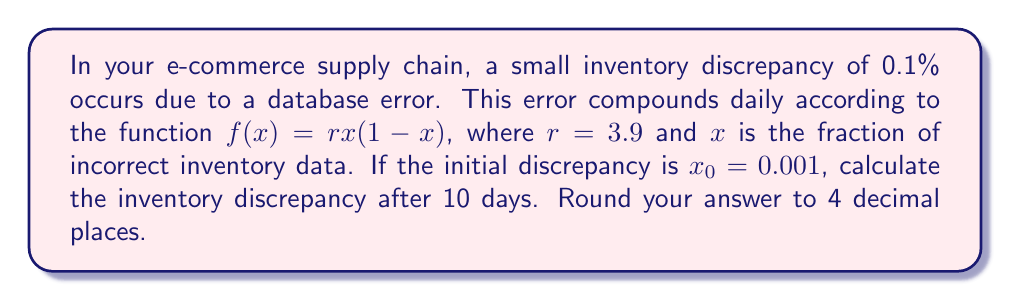Help me with this question. To solve this problem, we need to iterate the function $f(x) = rx(1-x)$ 10 times, starting with $x_0 = 0.001$. This is a classic example of the logistic map, which exhibits chaotic behavior for $r > 3.57$.

Let's calculate step by step:

1) $x_1 = f(x_0) = 3.9 \cdot 0.001 \cdot (1-0.001) = 0.0038961$

2) $x_2 = f(x_1) = 3.9 \cdot 0.0038961 \cdot (1-0.0038961) = 0.0151374$

3) $x_3 = f(x_2) = 3.9 \cdot 0.0151374 \cdot (1-0.0151374) = 0.0578654$

4) $x_4 = f(x_3) = 3.9 \cdot 0.0578654 \cdot (1-0.0578654) = 0.2126219$

5) $x_5 = f(x_4) = 3.9 \cdot 0.2126219 \cdot (1-0.2126219) = 0.6529799$

6) $x_6 = f(x_5) = 3.9 \cdot 0.6529799 \cdot (1-0.6529799) = 0.8837945$

7) $x_7 = f(x_6) = 3.9 \cdot 0.8837945 \cdot (1-0.8837945) = 0.4013228$

8) $x_8 = f(x_7) = 3.9 \cdot 0.4013228 \cdot (1-0.4013228) = 0.9366953$

9) $x_9 = f(x_8) = 3.9 \cdot 0.9366953 \cdot (1-0.9366953) = 0.2309506$

10) $x_{10} = f(x_9) = 3.9 \cdot 0.2309506 \cdot (1-0.2309506) = 0.6918755$

Rounding to 4 decimal places, we get 0.6919 or 69.19%.
Answer: 0.6919 